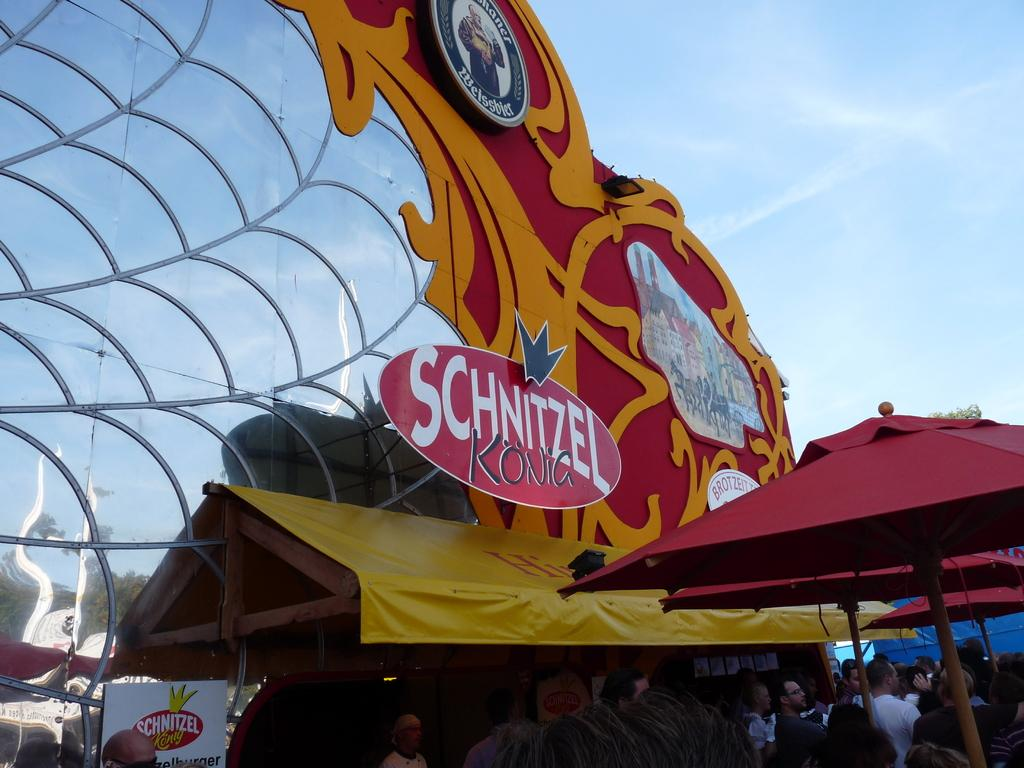<image>
Write a terse but informative summary of the picture. a building outside that says 'schnitzel kong' on it 